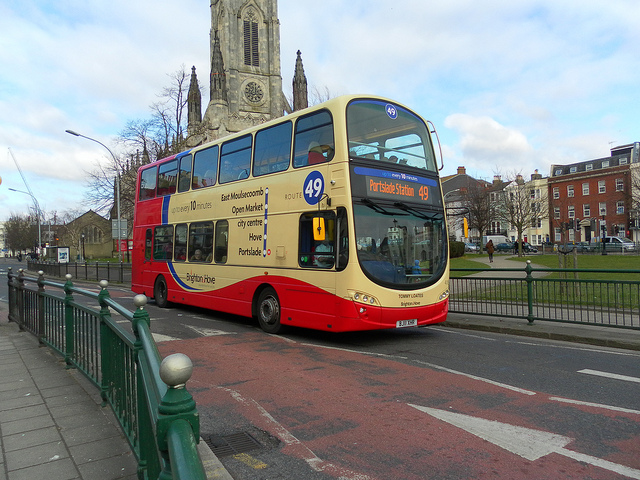Extract all visible text content from this image. East Moulstoomb Open Market dry centre Hove Portslade 49 Portstate ROUTE 49 